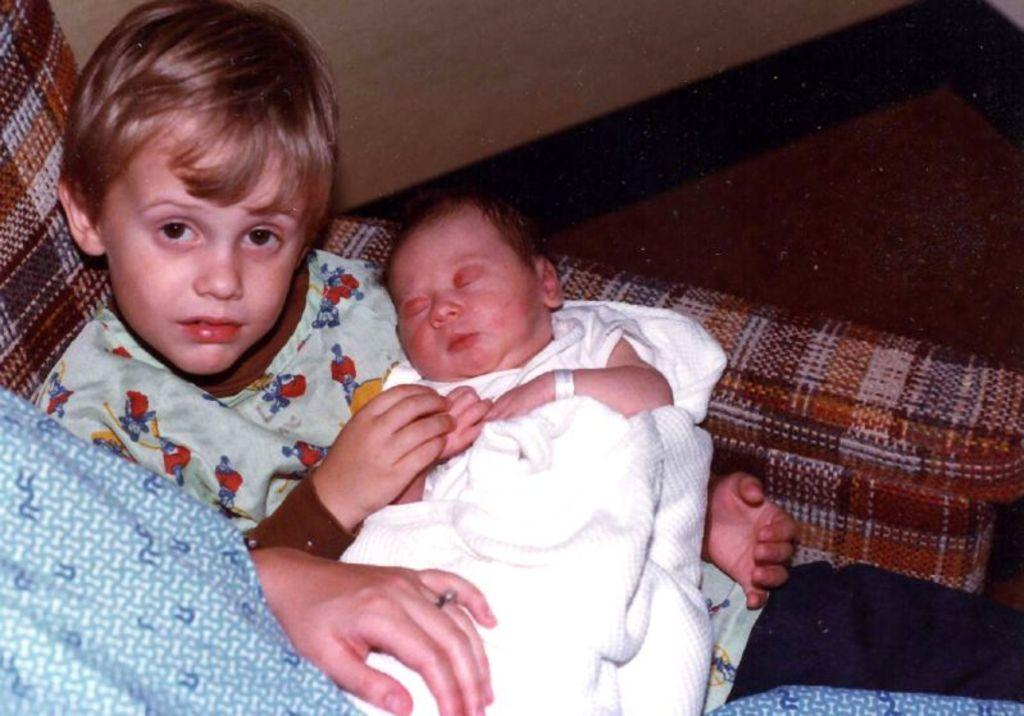What is located on the left side of the image? There is a small baby on the left side of the image. Can you describe the position of the second baby in the image? There is another small baby on the lap of the first baby. Where is the lady in the image? The lady is in the bottom left side of the image on a sofa. What type of linen is being used to cover the leaves in the image? There are no linens or leaves present in the image; it features two babies and a lady. What riddle can be solved by observing the image? There is no riddle present in the image; it is a simple scene with two babies and a lady. 